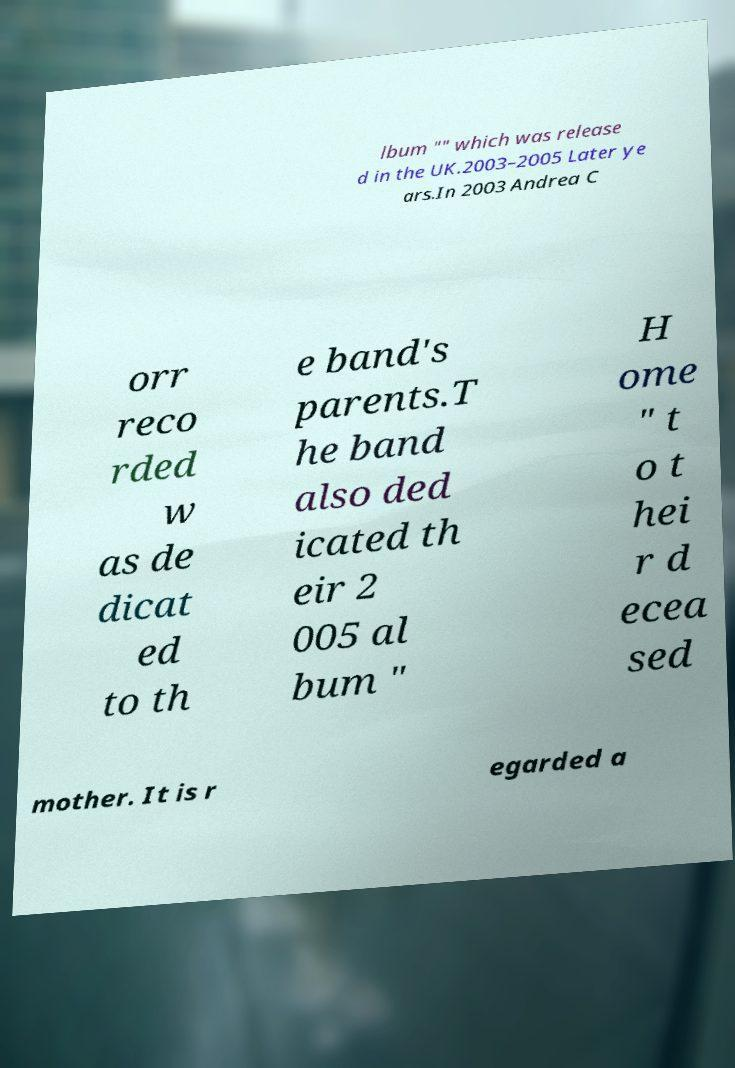Please identify and transcribe the text found in this image. lbum "" which was release d in the UK.2003–2005 Later ye ars.In 2003 Andrea C orr reco rded w as de dicat ed to th e band's parents.T he band also ded icated th eir 2 005 al bum " H ome " t o t hei r d ecea sed mother. It is r egarded a 